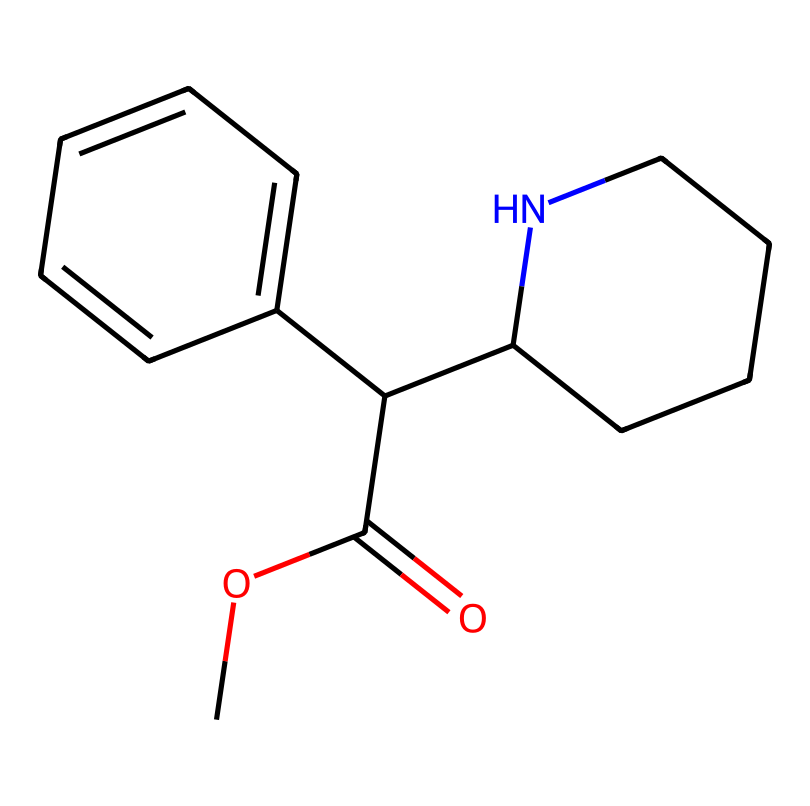What is the molecular formula of methylphenidate? To determine the molecular formula, count the number of carbon (C), hydrogen (H), nitrogen (N), and oxygen (O) atoms in the SMILES representation. In this case, the formula can be deduced as C(<countC>)H(<countH>)N(<countN>)O(<countO>), where there are 14 carbons, 19 hydrogens, 1 nitrogen, and 2 oxygens.
Answer: C14H19N2O2 How many rings are present in the structure of methylphenidate? By analyzing the SMILES representation, identify any cycles (rings) in the chemical. The structure shows one five-membered ring (the piperidine) and one six-membered aromatic ring, totaling two rings.
Answer: 2 Which functional groups are present in methylphenidate? Examine the chemical structure for recognizable functional groups. Methylphenidate contains an ester (indicated by the COC(=O) portion) and an amine, as seen in the piperidine ring.
Answer: ester, amine What is the most prominent feature of methylphenidate that aids in its function as a stimulant? Investigate the structural attributes that dictate the pharmacological properties of the chemical. Notably, the presence of a piperidine ring allows it to interact significantly with the dopamine receptors related to attention and concentration.
Answer: piperidine ring How does the presence of nitrogen in methylphenidate contribute to its pharmacological effects? Determine the role of nitrogen atoms in the context of drug activity. Nitrogen plays a critical role in forming cationic sites which can interact with neurotransmitter receptors in the brain, enhancing effects on attention and concentration.
Answer: cationic sites Why is methylphenidate classified as a central nervous system stimulant? Consider the chemical structure and its effects on neurotransmitter levels. Methylphenidate inhibits the reuptake of dopamine and norepinephrine, thus enhancing their availability in the synaptic cleft, which is characteristic of stimulants.
Answer: inhibits dopamine reuptake 